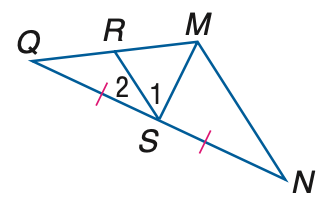Answer the mathemtical geometry problem and directly provide the correct option letter.
Question: If M S is a median of \triangle M N Q, Q S = 3 a - 14, S N = 2 a + 1, and m \angle M S Q = 7 a + 1, find the value of a.
Choices: A: 13 B: 14 C: 15 D: 16 C 